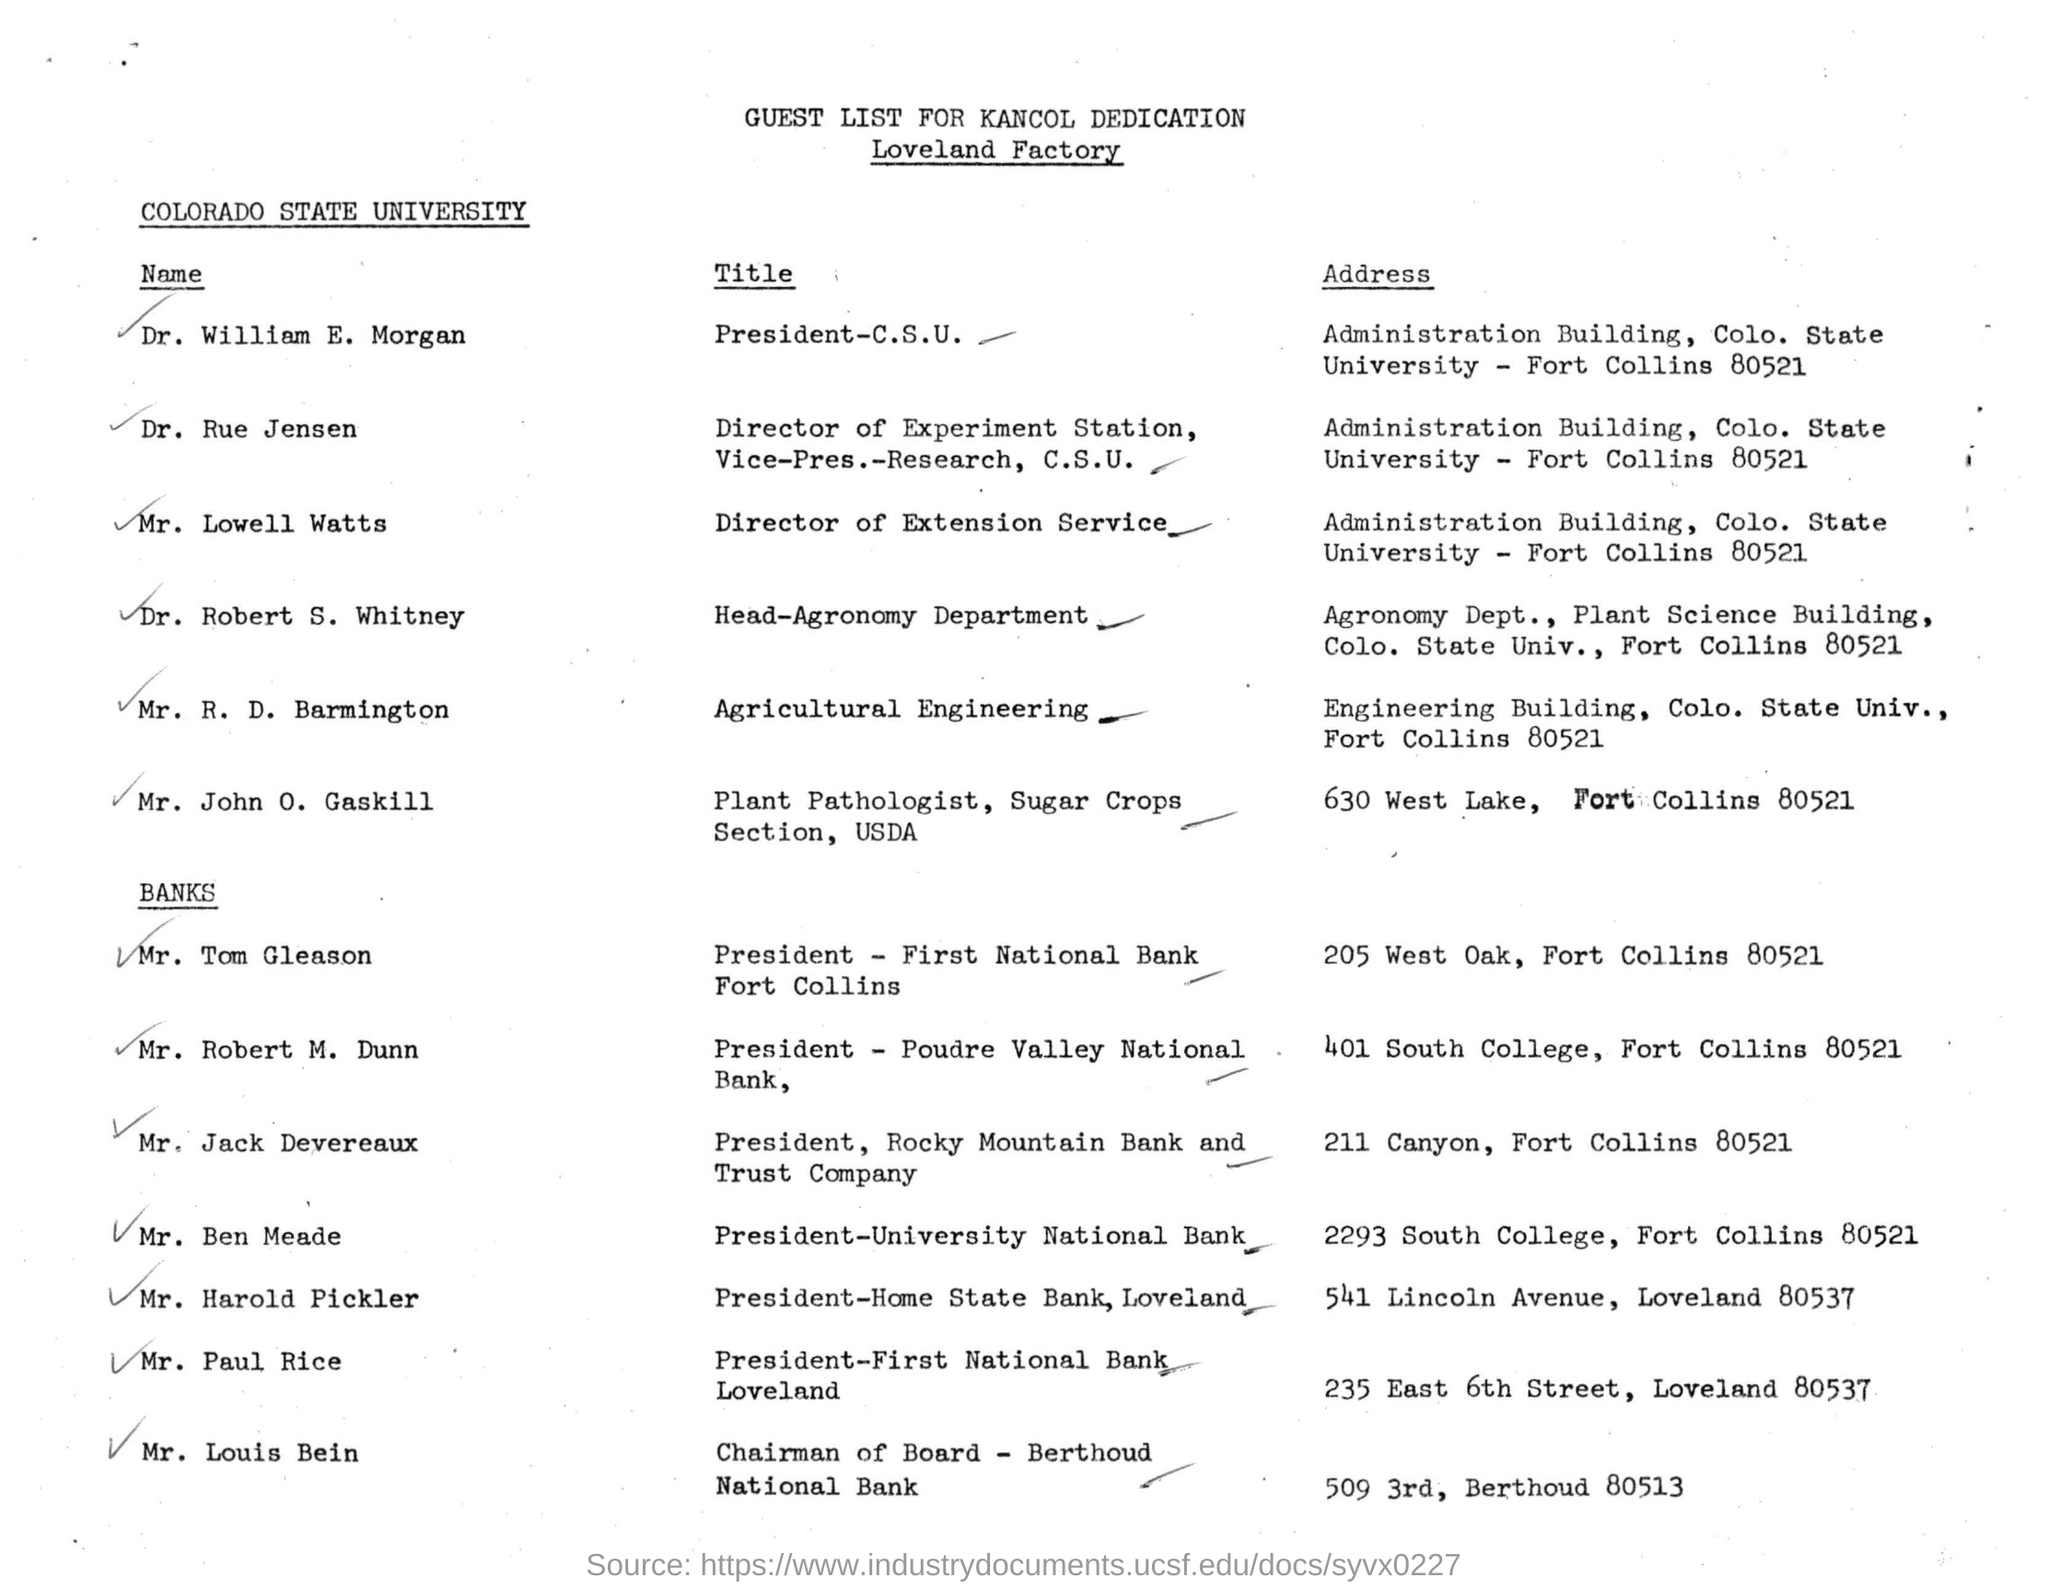Give some essential details in this illustration. The Colorado State University is the name of the university mentioned in the document. The President of First National Bank in Fort Collins is Mr. Tom Gleason. Dr. William E. Morgan is the president of California State University. 